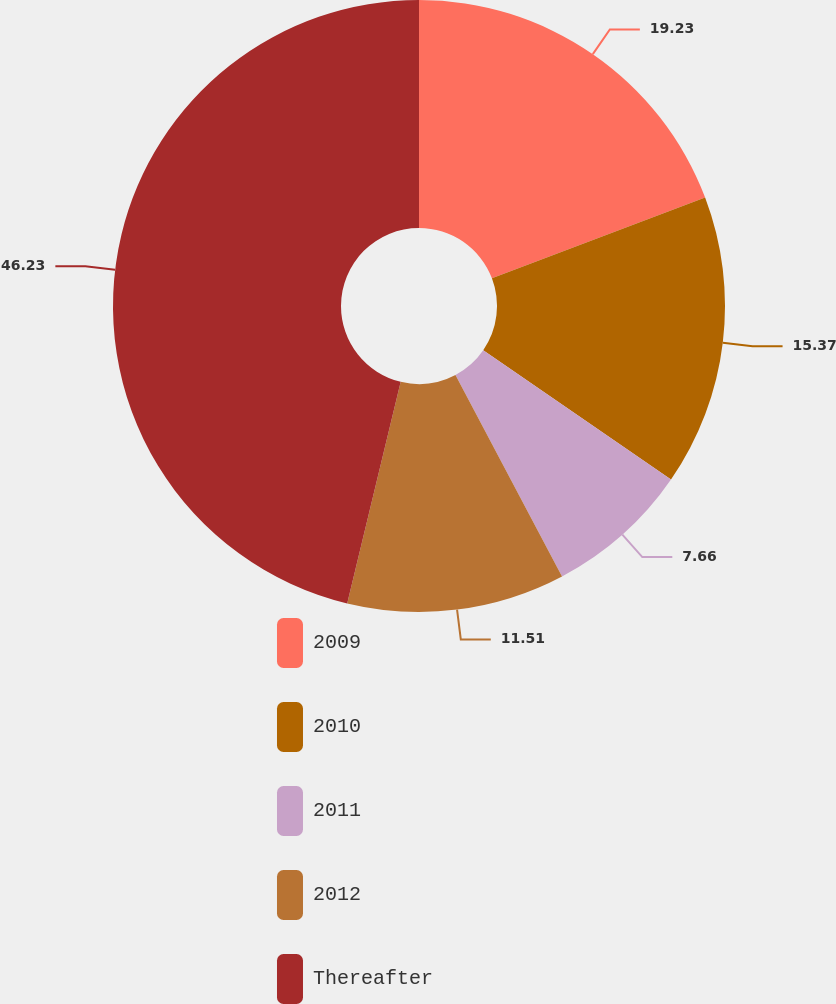<chart> <loc_0><loc_0><loc_500><loc_500><pie_chart><fcel>2009<fcel>2010<fcel>2011<fcel>2012<fcel>Thereafter<nl><fcel>19.23%<fcel>15.37%<fcel>7.66%<fcel>11.51%<fcel>46.23%<nl></chart> 